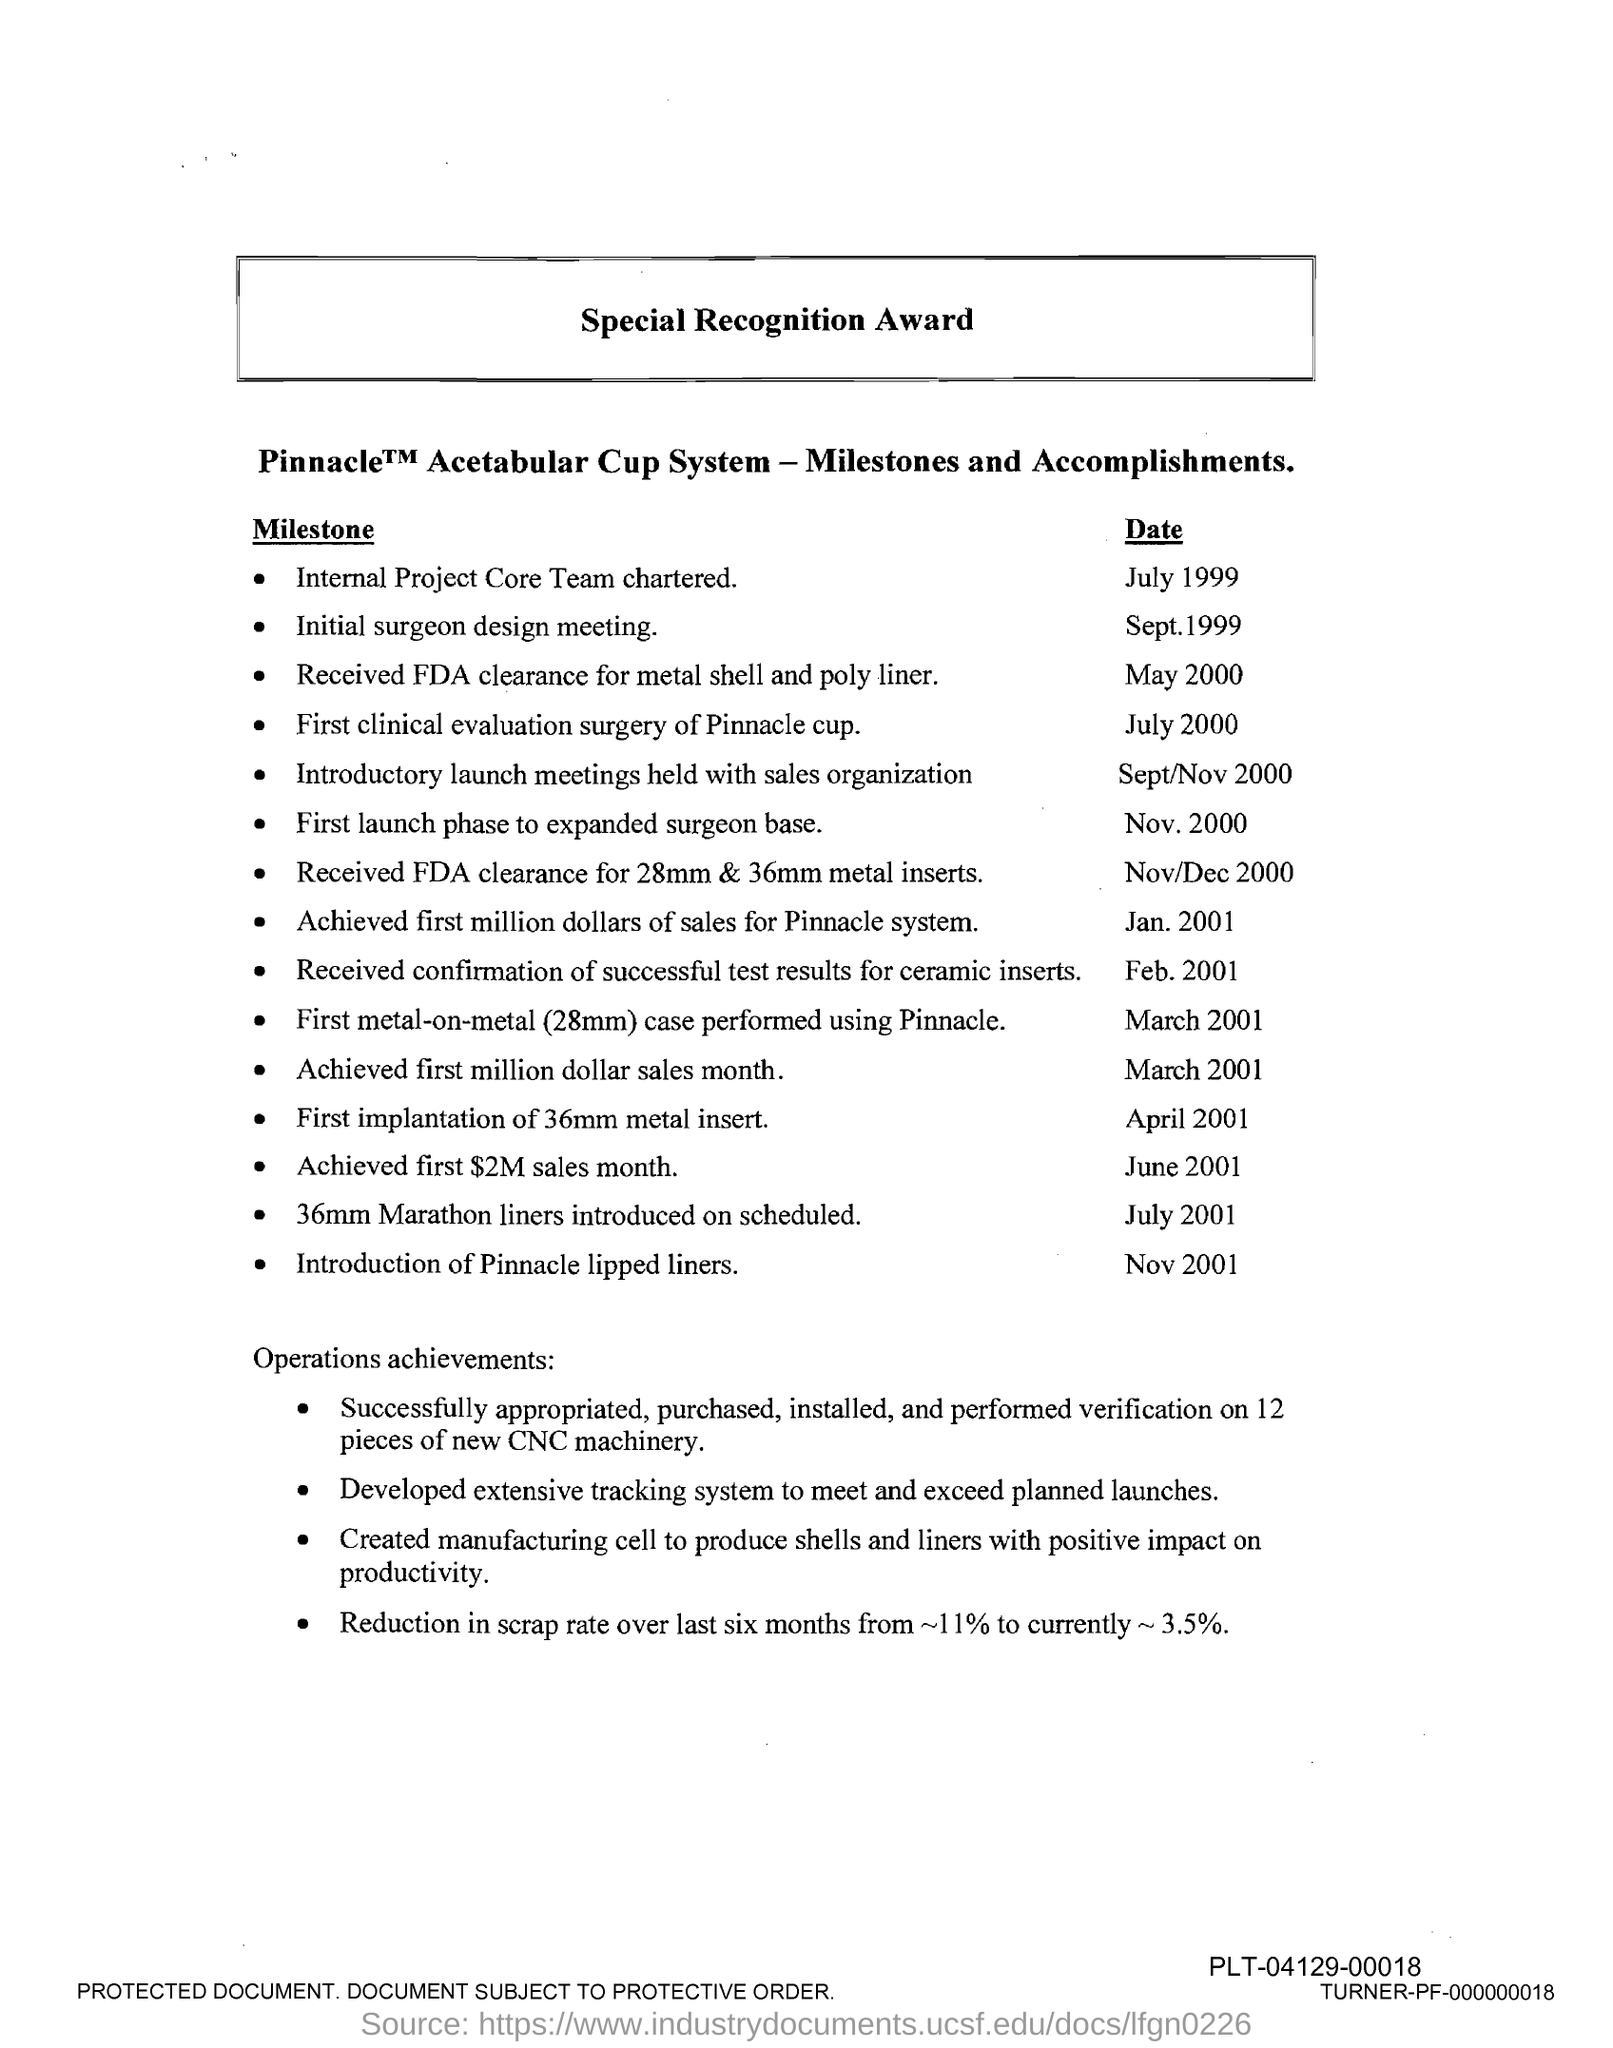Indicate a few pertinent items in this graphic. The internal project core team was chartered in July 1999. The pinnacle lipped liners were introduced in November 2001. The title of the document is Special Recognition Award. 